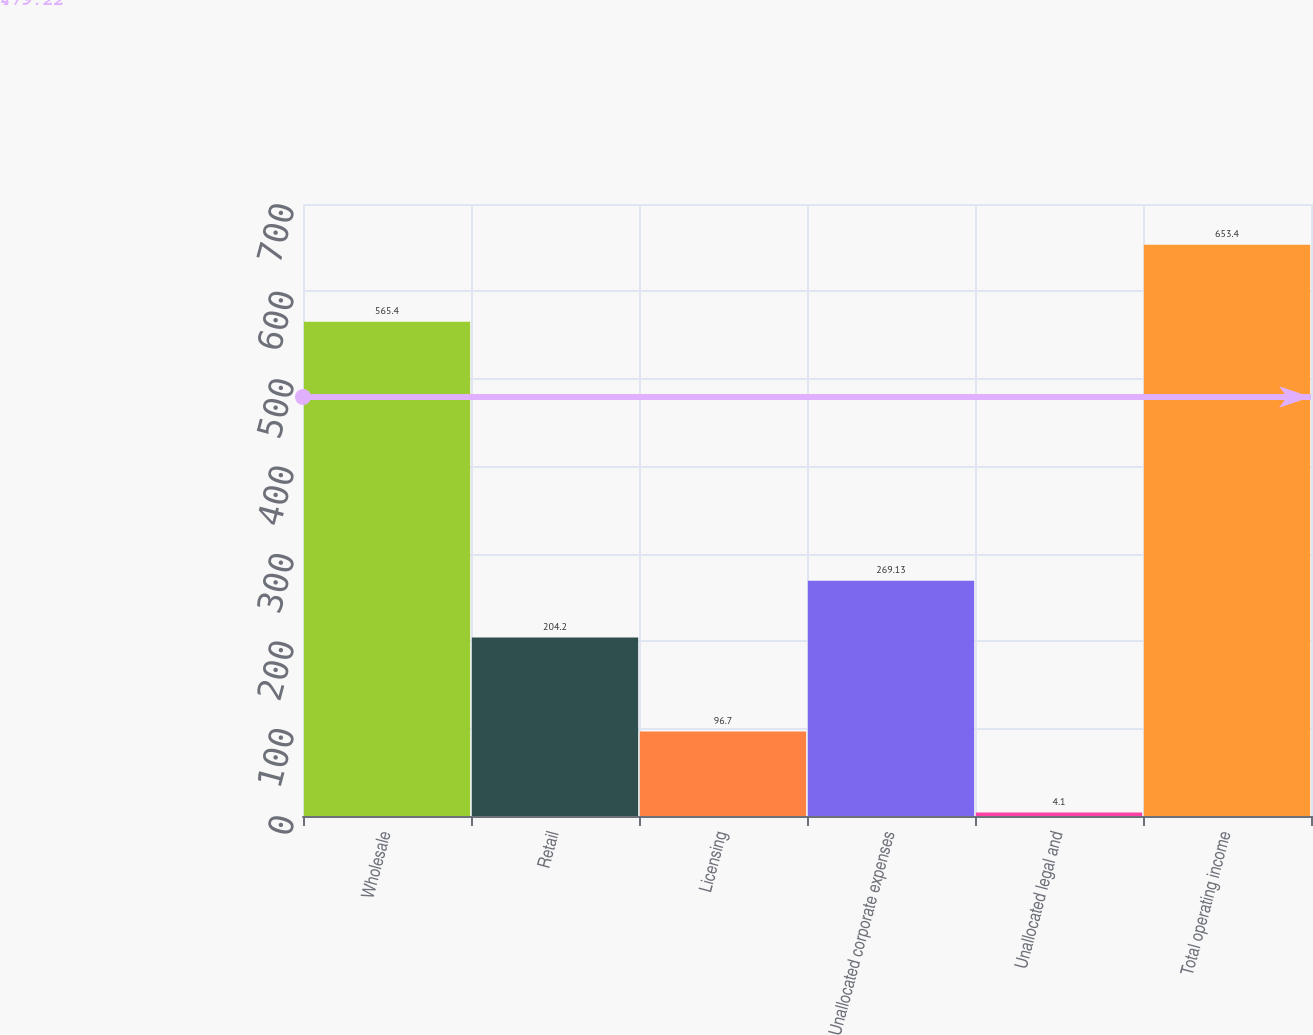Convert chart. <chart><loc_0><loc_0><loc_500><loc_500><bar_chart><fcel>Wholesale<fcel>Retail<fcel>Licensing<fcel>Unallocated corporate expenses<fcel>Unallocated legal and<fcel>Total operating income<nl><fcel>565.4<fcel>204.2<fcel>96.7<fcel>269.13<fcel>4.1<fcel>653.4<nl></chart> 